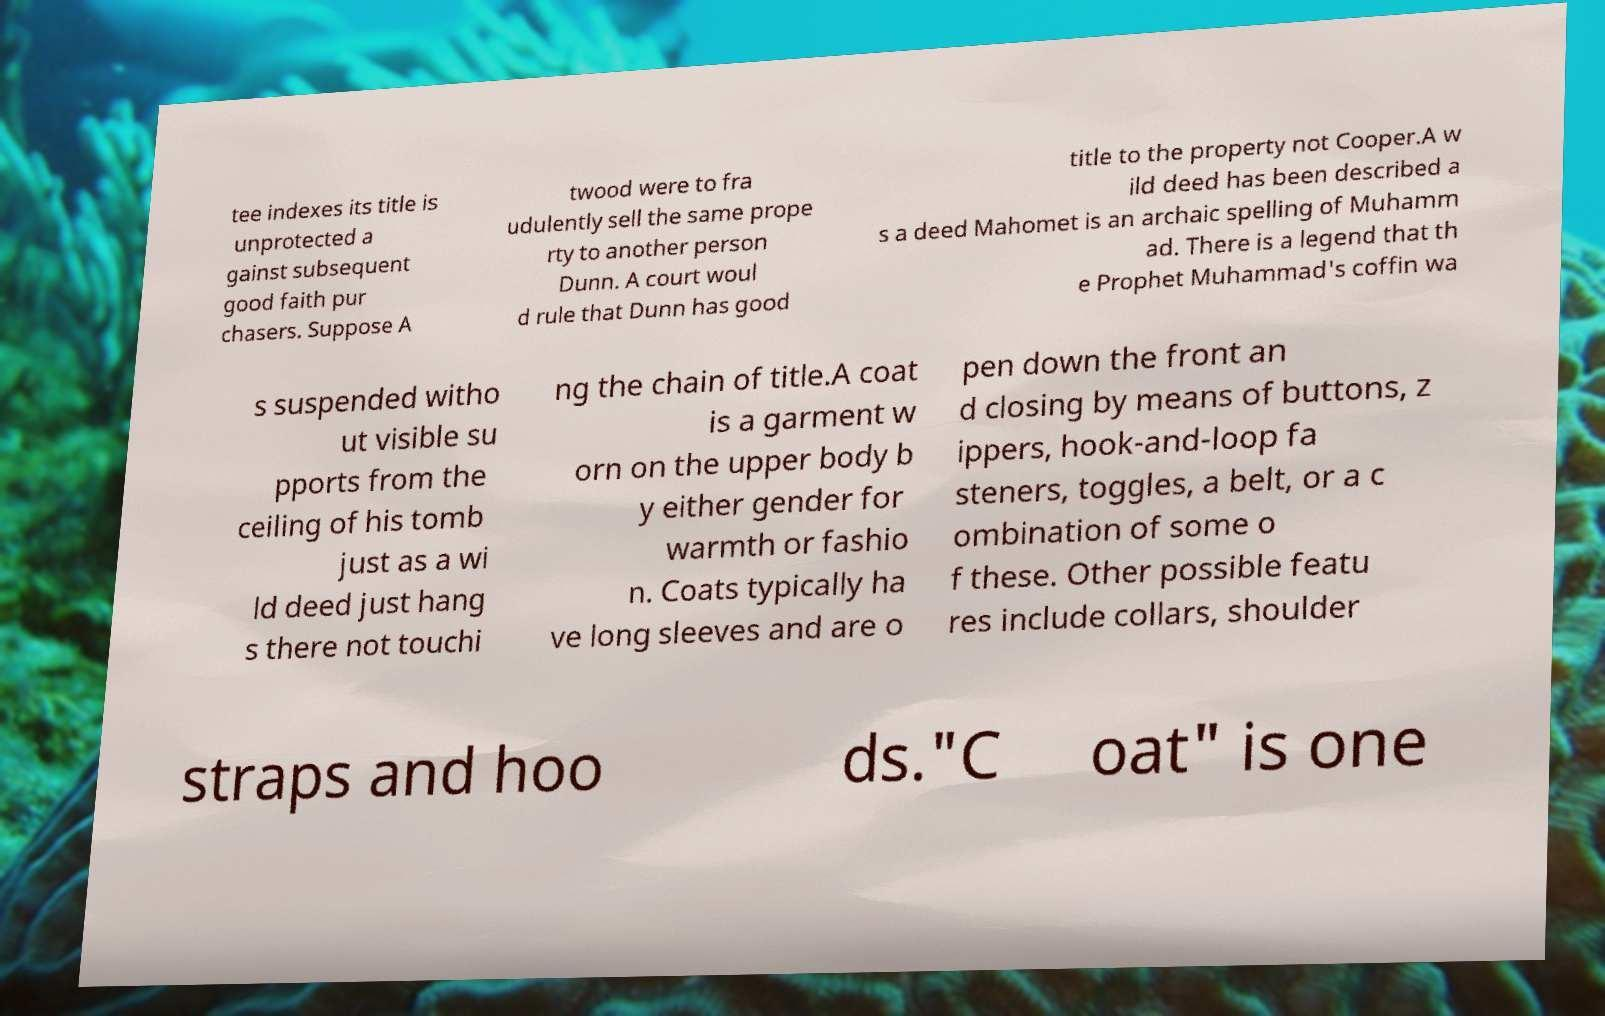Please read and relay the text visible in this image. What does it say? tee indexes its title is unprotected a gainst subsequent good faith pur chasers. Suppose A twood were to fra udulently sell the same prope rty to another person Dunn. A court woul d rule that Dunn has good title to the property not Cooper.A w ild deed has been described a s a deed Mahomet is an archaic spelling of Muhamm ad. There is a legend that th e Prophet Muhammad's coffin wa s suspended witho ut visible su pports from the ceiling of his tomb just as a wi ld deed just hang s there not touchi ng the chain of title.A coat is a garment w orn on the upper body b y either gender for warmth or fashio n. Coats typically ha ve long sleeves and are o pen down the front an d closing by means of buttons, z ippers, hook-and-loop fa steners, toggles, a belt, or a c ombination of some o f these. Other possible featu res include collars, shoulder straps and hoo ds."C oat" is one 